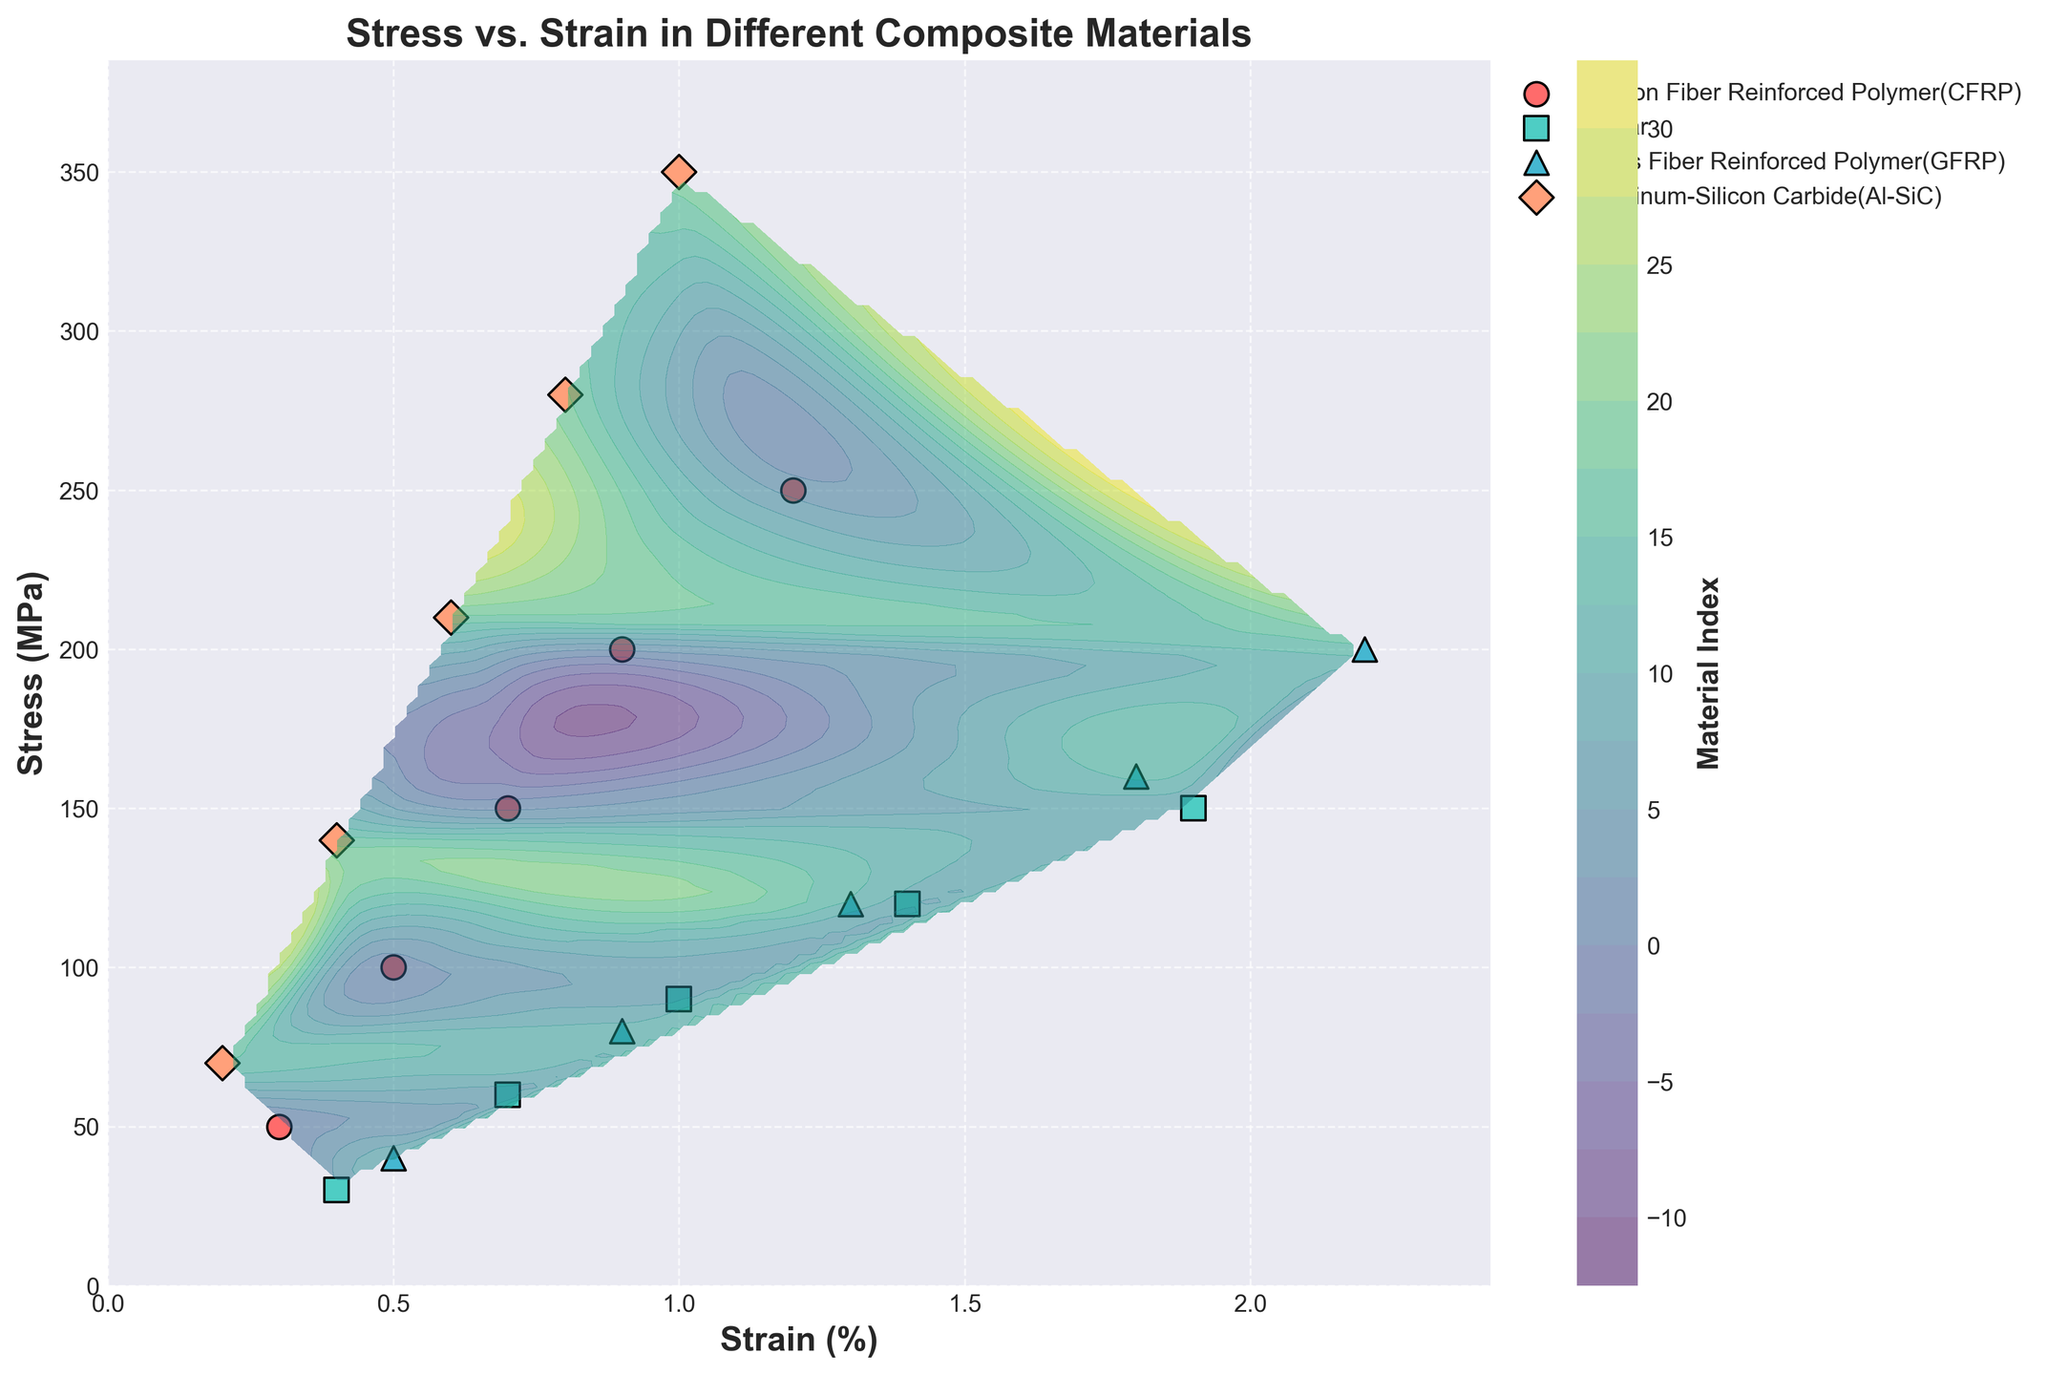What's the title of the plot? The title of the plot is displayed prominently at the top of the figure.
Answer: Stress vs. Strain in Different Composite Materials What are the x-axis and y-axis labels? The axis labels are shown along the edges of the plot. The x-axis label is along the horizontal edge, and the y-axis label is along the vertical edge.
Answer: Strain (%) and Stress (MPa) Which material has the highest stress value in the dataset? By observing the scatter points on the plot, the material labeled as the highest stress value will be the one positioned at the highest y-value on the plot.
Answer: Aluminum-Silicon Carbide (Al-SiC) How many unique materials are represented in the plot? Each unique material is represented by a different color and shape, all listed in the legend of the plot.
Answer: 4 Which material shows the steepest increase in stress with an increase in strain? By comparing the gradient of the scatter points' arrangement for each material, the one with the steepest slope from left to right has the steepest increase.
Answer: Aluminum-Silicon Carbide (Al-SiC) Between the strain values of 0.5% and 1.5%, which material has the greatest range in stress? Compare the vertical spread of points within these x-values for each material.
Answer: Glass Fiber Reinforced Polymer (GFRP) Which material has a strain of 1.0% and what's the corresponding stress value? Locate the scatter point at x = 1.0% strain and identify its y-value and corresponding material from the legend.
Answer: Kevlar, 150 MPa What is the material index range represented in the contour plot? The color bar (color legend) of the contour plot displays the range of material indices.
Answer: 0 to 18 (approximately) What is the approximate stress value for CFRP at a strain of 0.6%? Identify the scatter points close to 0.6% strain for CFRP and estimate its y-value.
Answer: 125 MPa (approximately) At a stress of 100 MPa, which material(s) shows up on the contour plot and what are their approximate strain values? Find the horizontal line at 100 MPa on the y-axis and see where it intersects with scatter points; then, refer to the x-axis for the strain values and the color/marker for the material(s).
Answer: CFRP (0.5%) and Al-SiC (0.3%) 